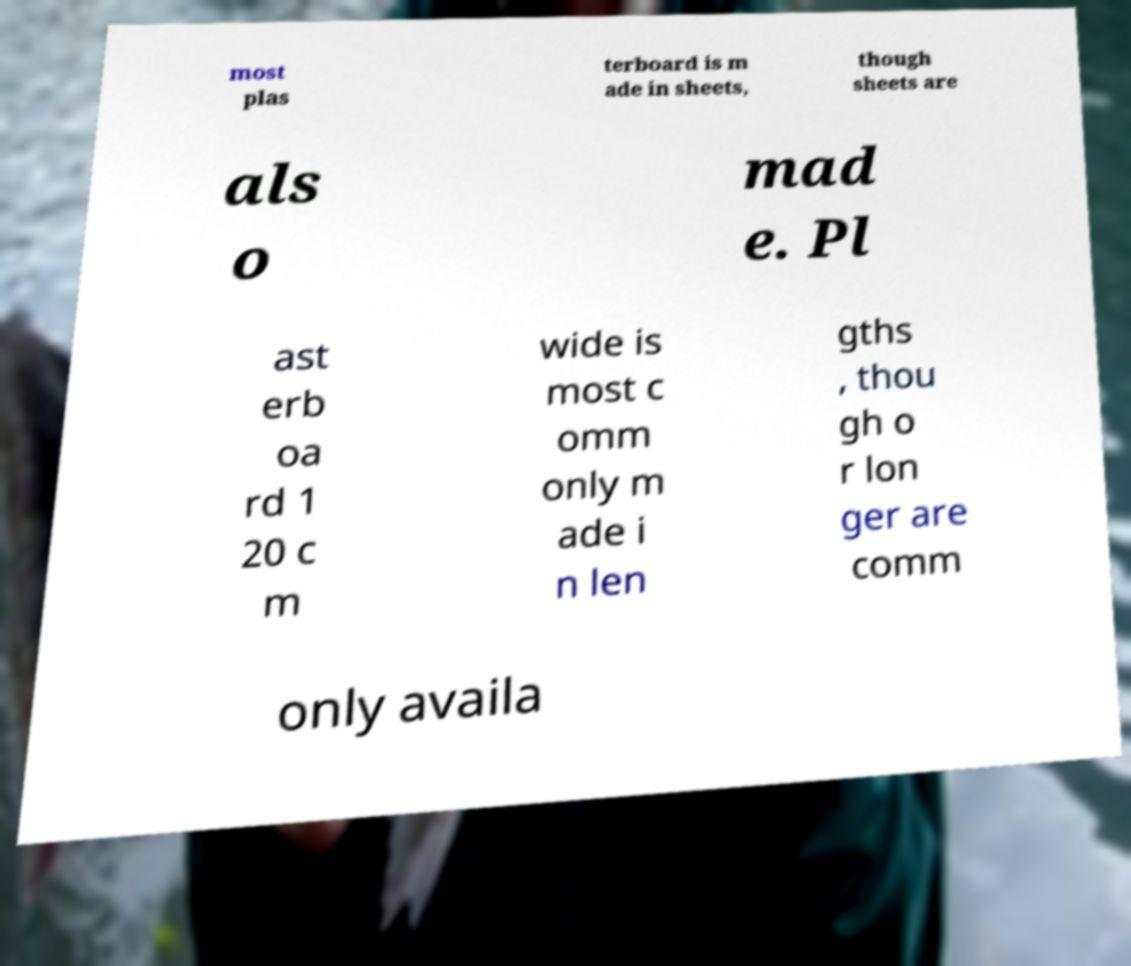Please identify and transcribe the text found in this image. most plas terboard is m ade in sheets, though sheets are als o mad e. Pl ast erb oa rd 1 20 c m wide is most c omm only m ade i n len gths , thou gh o r lon ger are comm only availa 